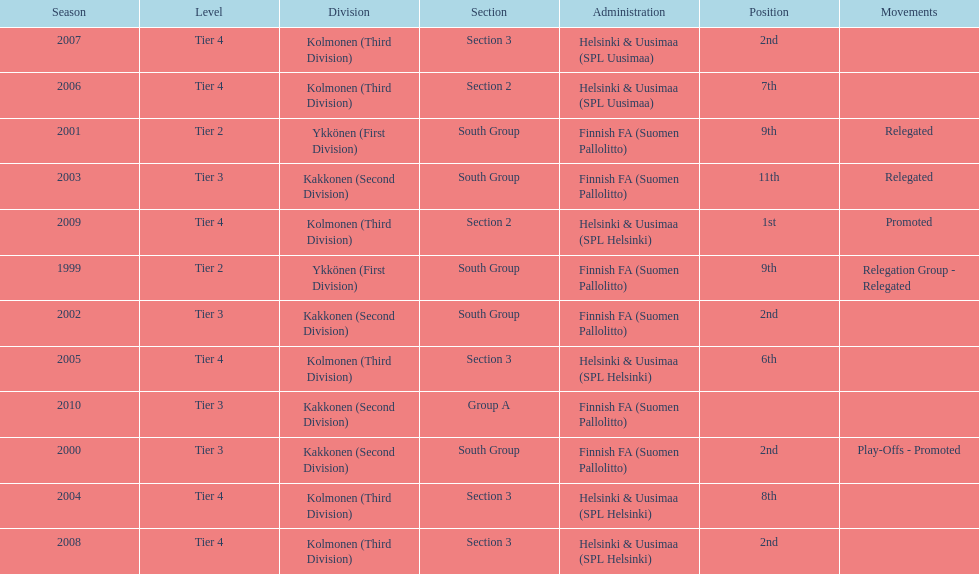Of the third division, how many were in section3? 4. Write the full table. {'header': ['Season', 'Level', 'Division', 'Section', 'Administration', 'Position', 'Movements'], 'rows': [['2007', 'Tier 4', 'Kolmonen (Third Division)', 'Section 3', 'Helsinki & Uusimaa (SPL Uusimaa)', '2nd', ''], ['2006', 'Tier 4', 'Kolmonen (Third Division)', 'Section 2', 'Helsinki & Uusimaa (SPL Uusimaa)', '7th', ''], ['2001', 'Tier 2', 'Ykkönen (First Division)', 'South Group', 'Finnish FA (Suomen Pallolitto)', '9th', 'Relegated'], ['2003', 'Tier 3', 'Kakkonen (Second Division)', 'South Group', 'Finnish FA (Suomen Pallolitto)', '11th', 'Relegated'], ['2009', 'Tier 4', 'Kolmonen (Third Division)', 'Section 2', 'Helsinki & Uusimaa (SPL Helsinki)', '1st', 'Promoted'], ['1999', 'Tier 2', 'Ykkönen (First Division)', 'South Group', 'Finnish FA (Suomen Pallolitto)', '9th', 'Relegation Group - Relegated'], ['2002', 'Tier 3', 'Kakkonen (Second Division)', 'South Group', 'Finnish FA (Suomen Pallolitto)', '2nd', ''], ['2005', 'Tier 4', 'Kolmonen (Third Division)', 'Section 3', 'Helsinki & Uusimaa (SPL Helsinki)', '6th', ''], ['2010', 'Tier 3', 'Kakkonen (Second Division)', 'Group A', 'Finnish FA (Suomen Pallolitto)', '', ''], ['2000', 'Tier 3', 'Kakkonen (Second Division)', 'South Group', 'Finnish FA (Suomen Pallolitto)', '2nd', 'Play-Offs - Promoted'], ['2004', 'Tier 4', 'Kolmonen (Third Division)', 'Section 3', 'Helsinki & Uusimaa (SPL Helsinki)', '8th', ''], ['2008', 'Tier 4', 'Kolmonen (Third Division)', 'Section 3', 'Helsinki & Uusimaa (SPL Helsinki)', '2nd', '']]} 